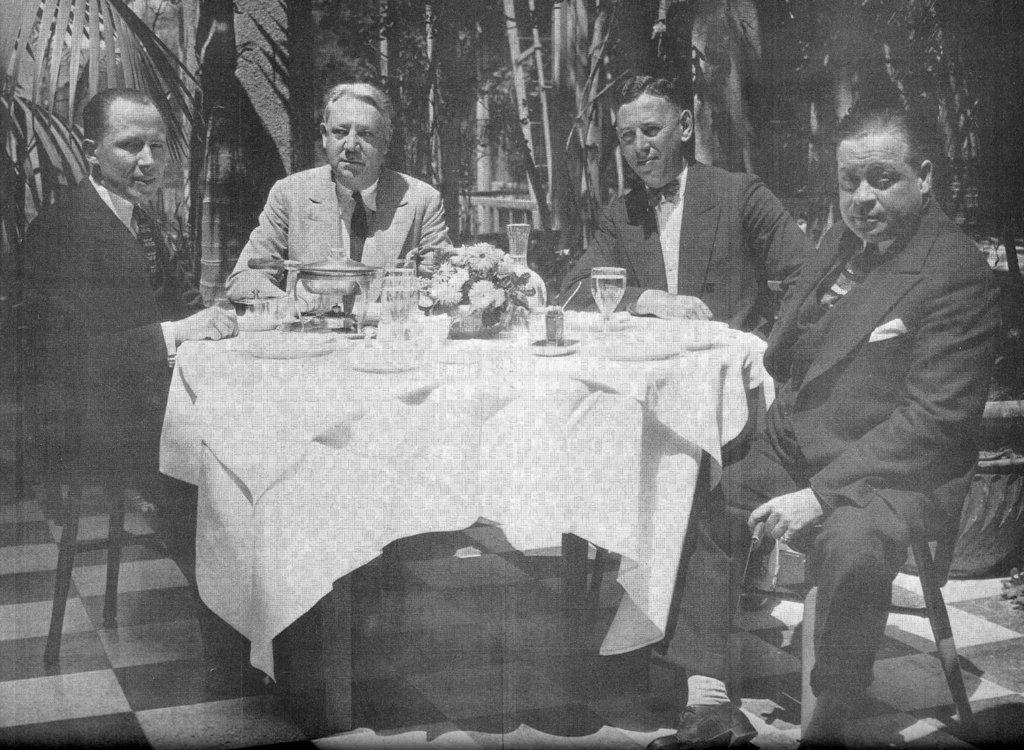How many people are in the image? There are four men in the image. What are the men doing in the image? The men are sitting on chairs. What is in front of the men? There is a table in front of the men. What can be seen on the table? There are objects on the table. What is visible in the background of the image? There are trees in the background of the image. Is there a maid in the image, and what is she doing? There is no maid present in the image. 